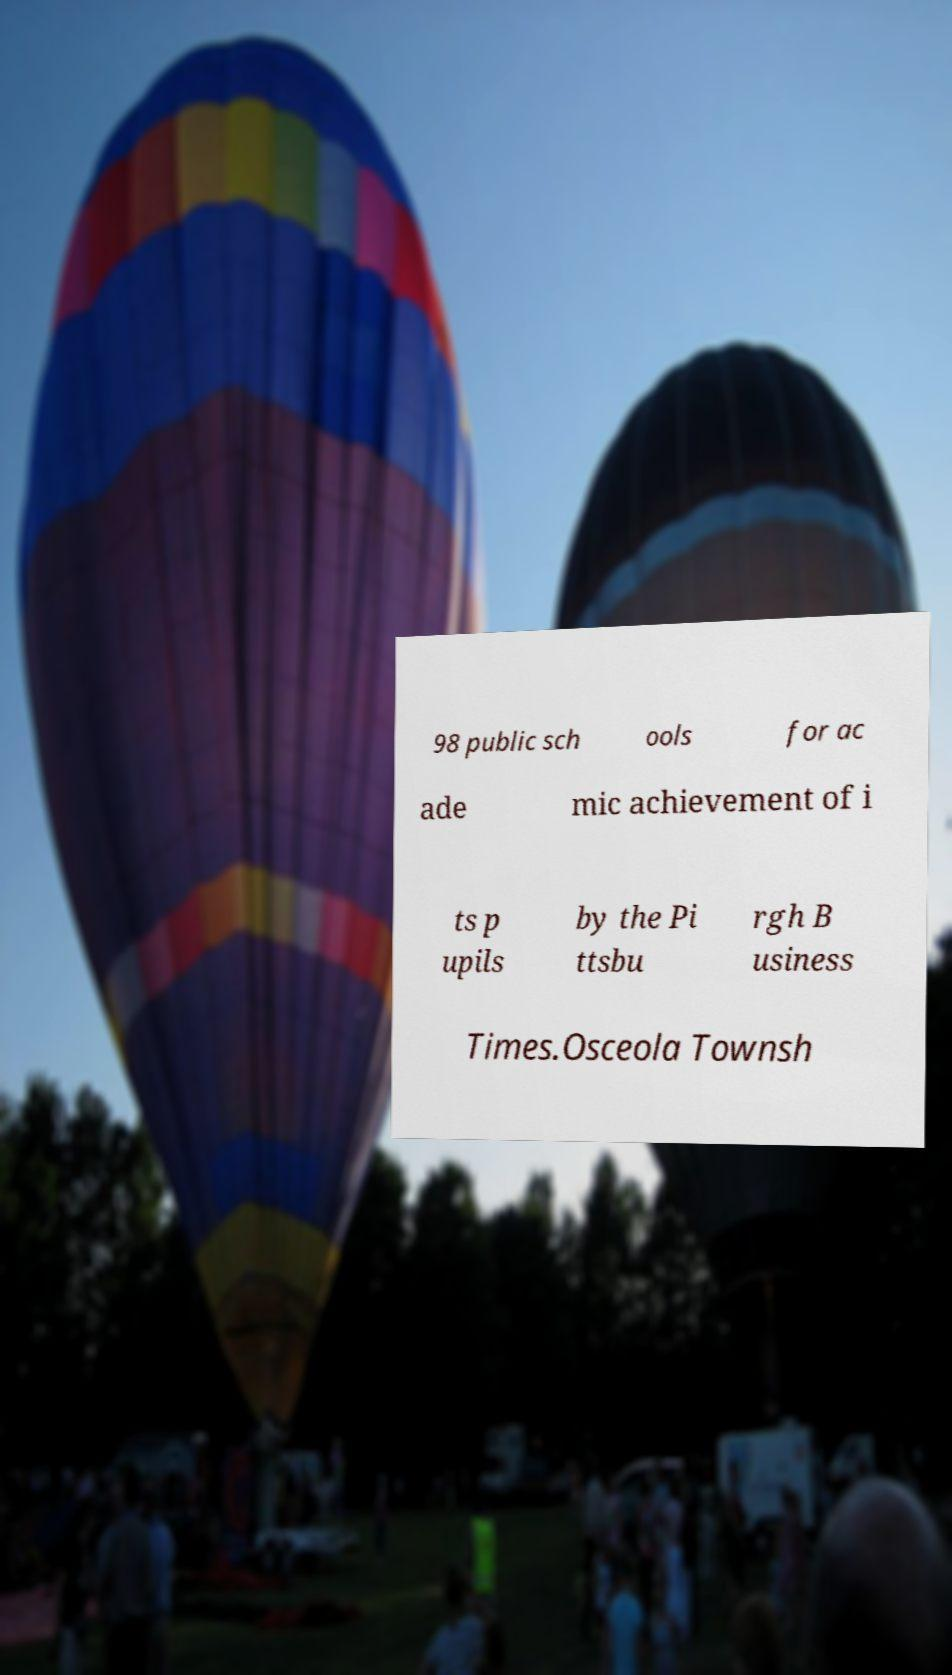There's text embedded in this image that I need extracted. Can you transcribe it verbatim? 98 public sch ools for ac ade mic achievement of i ts p upils by the Pi ttsbu rgh B usiness Times.Osceola Townsh 